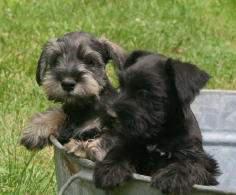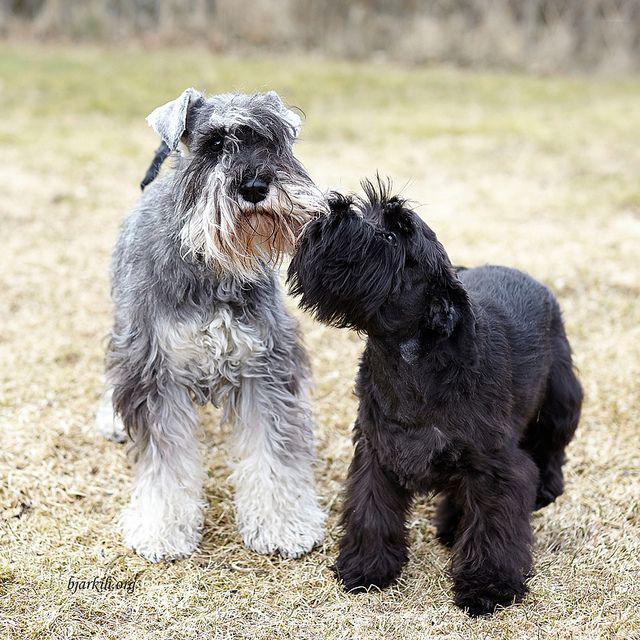The first image is the image on the left, the second image is the image on the right. For the images displayed, is the sentence "Both images show side-by-side schnauzer dogs with faces that look ahead instead of at the side." factually correct? Answer yes or no. No. 